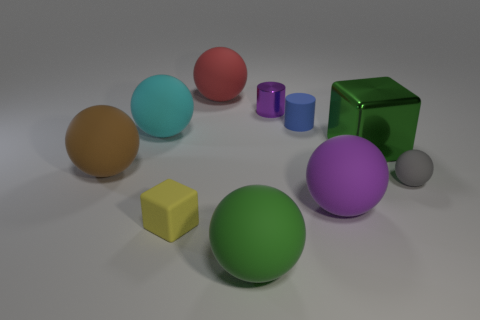Subtract all purple balls. How many balls are left? 5 Subtract all big green matte spheres. How many spheres are left? 5 Subtract all cyan balls. Subtract all brown cylinders. How many balls are left? 5 Subtract all cylinders. How many objects are left? 8 Add 9 small gray balls. How many small gray balls are left? 10 Add 4 shiny things. How many shiny things exist? 6 Subtract 0 blue cubes. How many objects are left? 10 Subtract all tiny matte blocks. Subtract all green cubes. How many objects are left? 8 